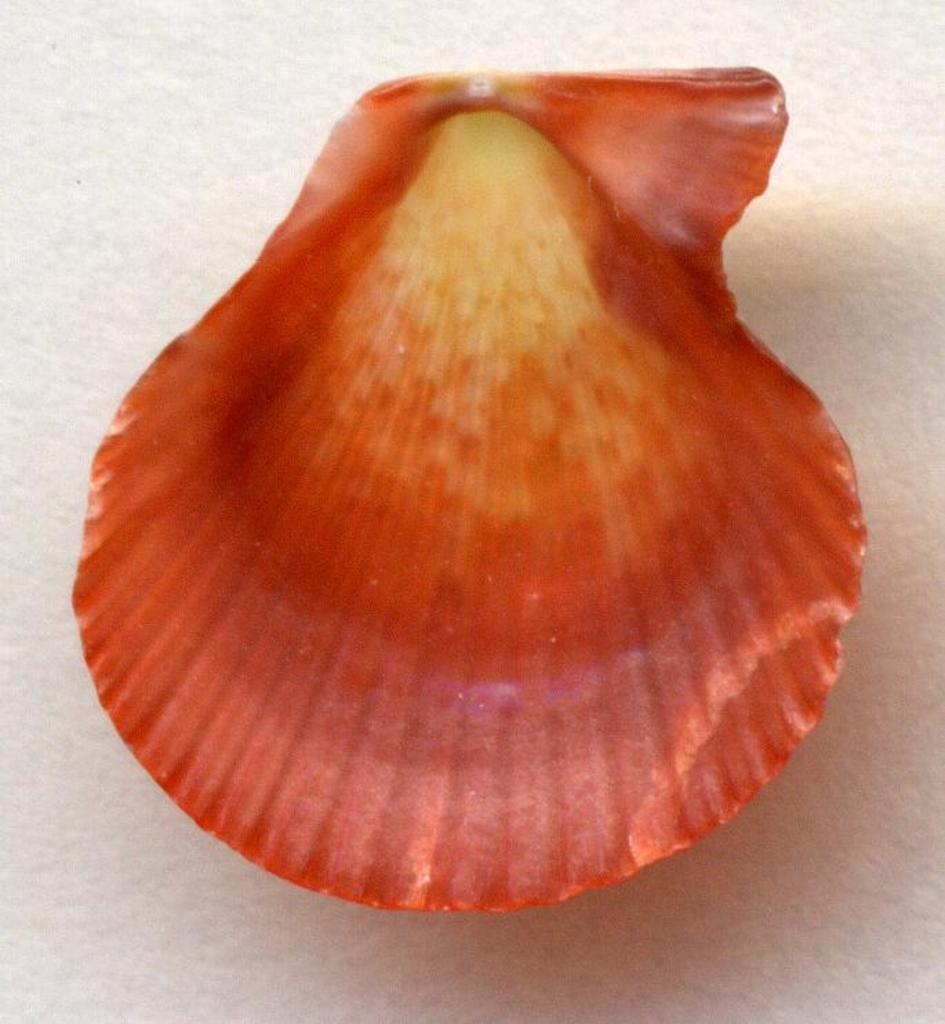What is the color of the shell in the image? The shell in the image is red. What is the color of the surface on which the shell is placed? The shell is on a white color surface. How many trees are visible in the image? There are no trees visible in the image; it only features a red shell on a white surface. What type of sign is present in the image? There is no sign present in the image; it only features a red shell on a white surface. 